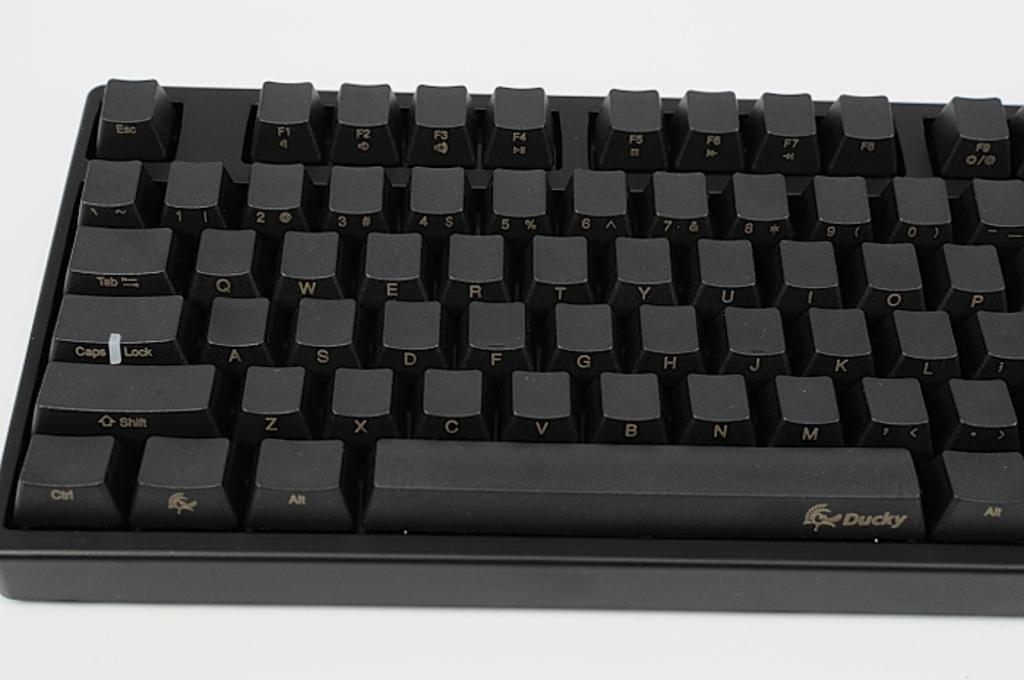Provide a one-sentence caption for the provided image. The black keyboard shown is made by the company Ducky. 